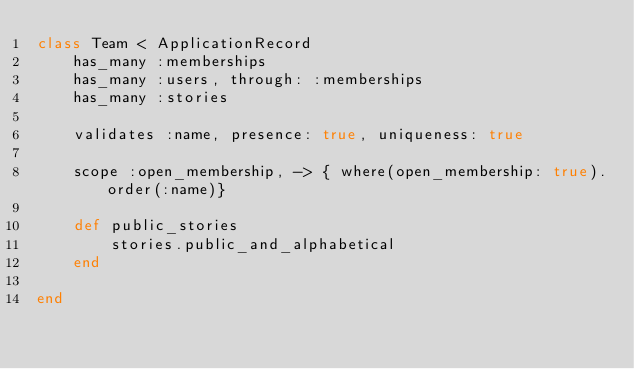Convert code to text. <code><loc_0><loc_0><loc_500><loc_500><_Ruby_>class Team < ApplicationRecord
	has_many :memberships
	has_many :users, through: :memberships
	has_many :stories

	validates :name, presence: true, uniqueness: true

	scope :open_membership, -> { where(open_membership: true).order(:name)}

	def public_stories
		stories.public_and_alphabetical
	end

end
</code> 